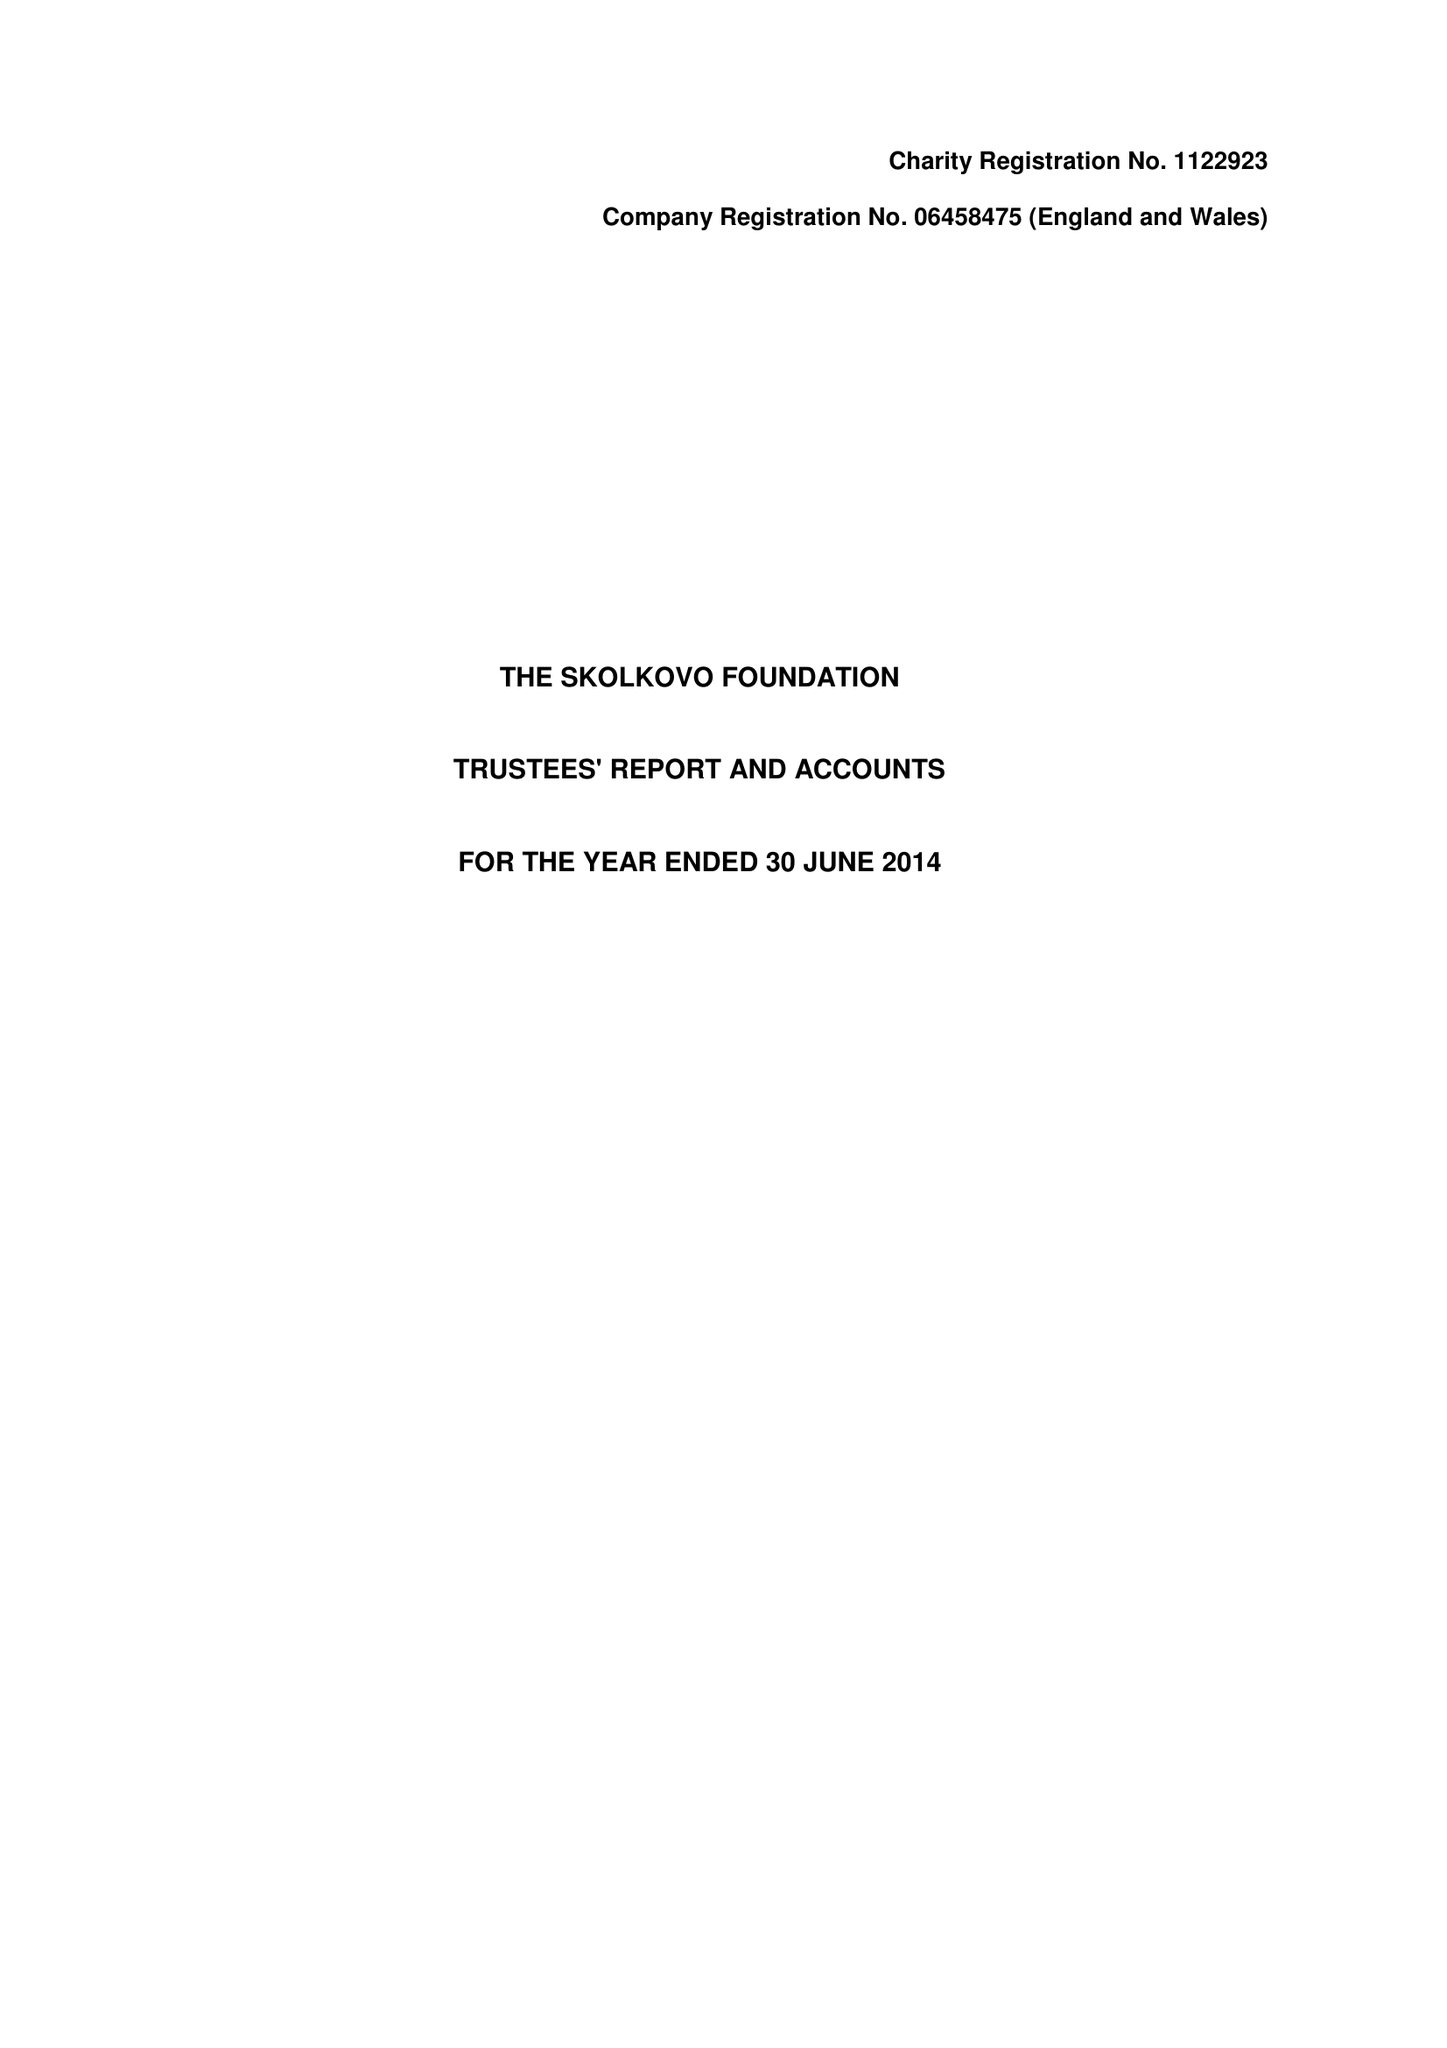What is the value for the address__street_line?
Answer the question using a single word or phrase. None 